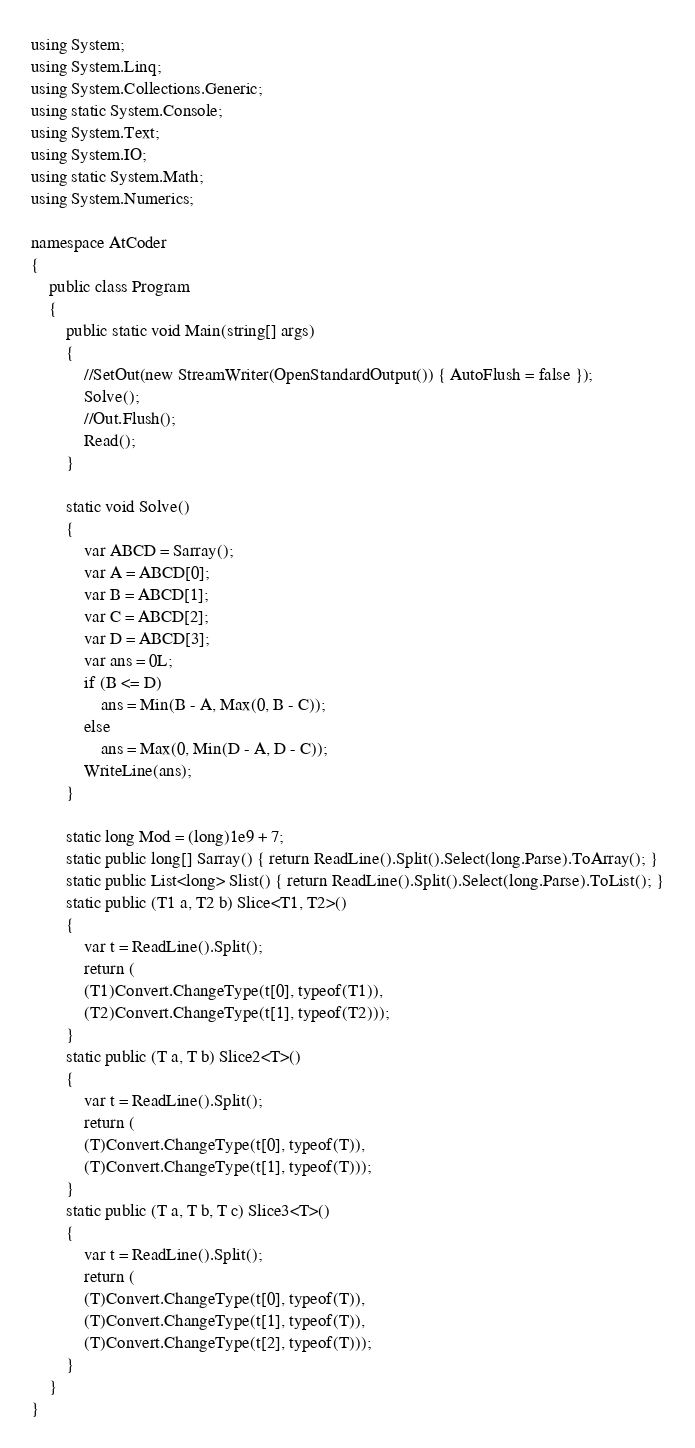<code> <loc_0><loc_0><loc_500><loc_500><_C#_>using System;
using System.Linq;
using System.Collections.Generic;
using static System.Console;
using System.Text;
using System.IO;
using static System.Math;
using System.Numerics;

namespace AtCoder
{
    public class Program
    {
        public static void Main(string[] args)
        {
            //SetOut(new StreamWriter(OpenStandardOutput()) { AutoFlush = false });
            Solve();
            //Out.Flush();
            Read();
        }

        static void Solve()
        {
            var ABCD = Sarray();
            var A = ABCD[0];
            var B = ABCD[1];
            var C = ABCD[2];
            var D = ABCD[3];
            var ans = 0L;
            if (B <= D)
                ans = Min(B - A, Max(0, B - C));
            else
                ans = Max(0, Min(D - A, D - C));
            WriteLine(ans);
        }

        static long Mod = (long)1e9 + 7;
        static public long[] Sarray() { return ReadLine().Split().Select(long.Parse).ToArray(); }
        static public List<long> Slist() { return ReadLine().Split().Select(long.Parse).ToList(); }
        static public (T1 a, T2 b) Slice<T1, T2>()
        {
            var t = ReadLine().Split();
            return (
            (T1)Convert.ChangeType(t[0], typeof(T1)),
            (T2)Convert.ChangeType(t[1], typeof(T2)));
        }
        static public (T a, T b) Slice2<T>()
        {
            var t = ReadLine().Split();
            return (
            (T)Convert.ChangeType(t[0], typeof(T)),
            (T)Convert.ChangeType(t[1], typeof(T)));
        }
        static public (T a, T b, T c) Slice3<T>()
        {
            var t = ReadLine().Split();
            return (
            (T)Convert.ChangeType(t[0], typeof(T)),
            (T)Convert.ChangeType(t[1], typeof(T)),
            (T)Convert.ChangeType(t[2], typeof(T)));
        }
    }
}</code> 